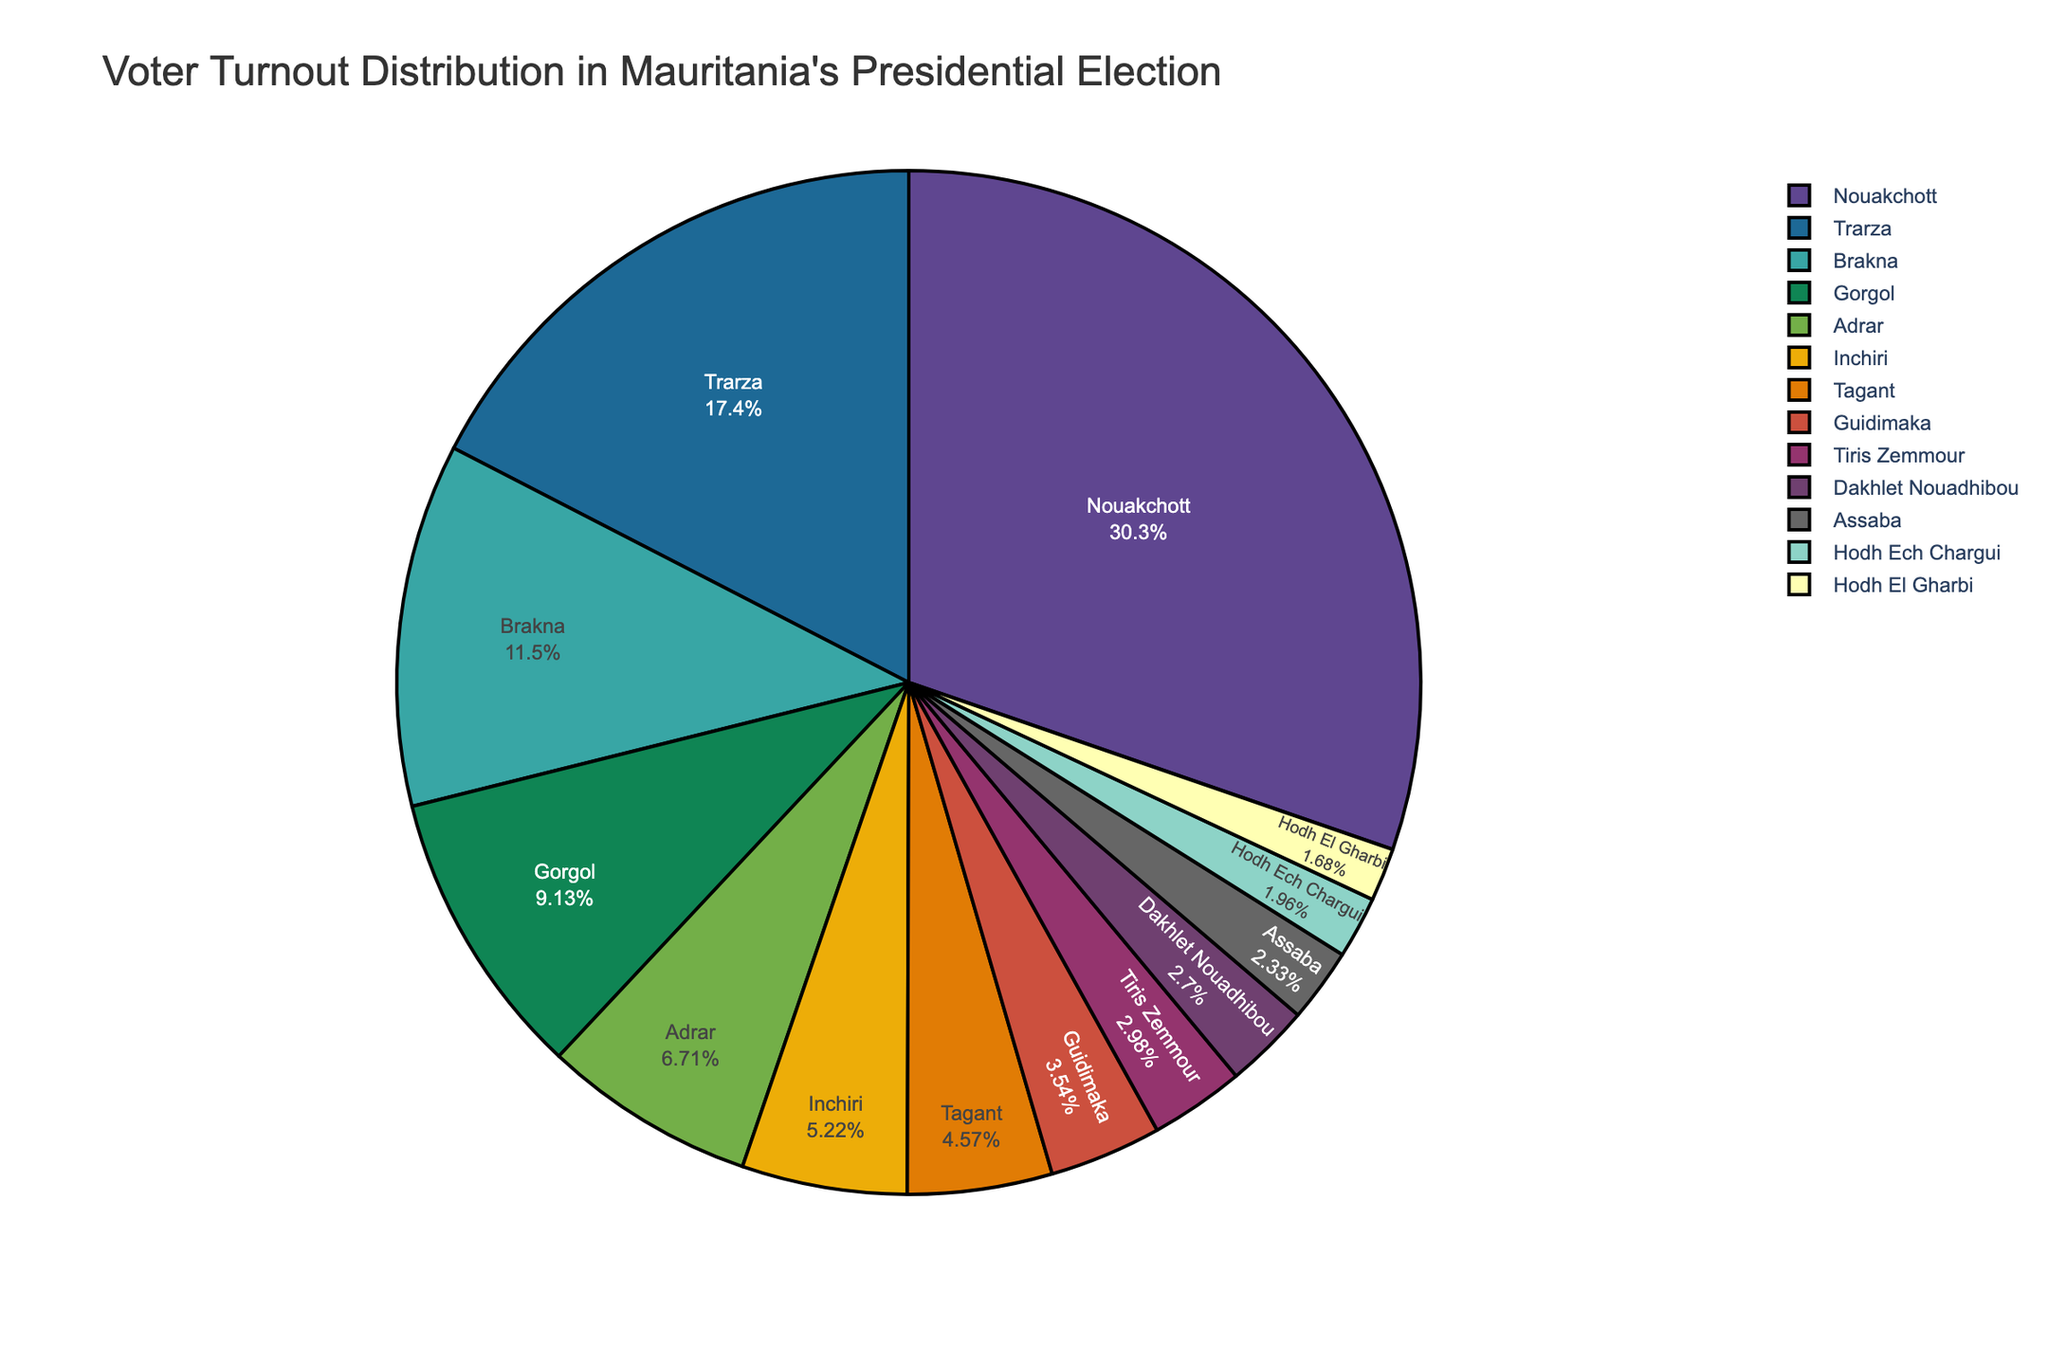What percentage of voter turnout is represented by Nouakchott? Look at the pie chart and find Nouakchott. The percentage of voter turnout for Nouakchott is directly shown next to its label.
Answer: 32.5% Which region has the smallest voter turnout percentage and what is that percentage? Find the smallest segment in the pie chart and identify the corresponding region. Look at the label of that region to find the voter turnout percentage.
Answer: Hodh El Gharbi, 1.8% What is the combined voter turnout percentage for Brakna and Gorgol? Find the segments for Brakna and Gorgol in the pie chart. Add their voter turnout percentages: 12.3% (Brakna) + 9.8% (Gorgol).
Answer: 22.1% Compare the voter turnout percentages of Trarza and Tiris Zemmour. Which region has a higher voter turnout? Locate the segments for Trarza and Tiris Zemmour in the pie chart. Compare the percentages given: 18.7% for Trarza and 3.2% for Tiris Zemmour.
Answer: Trarza What is the difference in voter turnout percentage between Inchiri and Adrar? Find the segments for Inchiri and Adrar in the pie chart. Subtract the smaller percentage from the larger one: 7.2% - 5.6%.
Answer: 1.6% How does the voter turnout percentage of Assaba compare to that of Tagant? Look at the pie chart segments for Assaba and Tagant and note their percentages: 2.5% for Assaba and 4.9% for Tagant.
Answer: Assaba has a lower voter turnout than Tagant Which regions have a voter turnout percentage below 5%? Identify segments in the pie chart with percentages below 5%. The regions are Inchiri, Tagant, Guidimaka, Tiris Zemmour, Dakhlet Nouadhibou, Assaba, Hodh Ech Chargui, and Hodh El Gharbi.
Answer: Inchiri, Tagant, Guidimaka, Tiris Zemmour, Dakhlet Nouadhibou, Assaba, Hodh Ech Chargui, Hodh El Gharbi What is the total voter turnout percentage for all regions except Nouakchott? Subtract Nouakchott's percentage (32.5%) from 100% (the total percentage).
Answer: 67.5% Please compare the combined voter turnout percentage of Hodh Ech Chargui, Hodh El Gharbi, and Assaba with that of Trarza. Which is higher? Find the segments for Hodh Ech Chargui, Hodh El Gharbi, and Assaba and sum their percentages: 2.1% + 1.8% + 2.5% = 6.4%. Compare this with Trarza's percentage of 18.7%.
Answer: Trarza is higher What regions have a voter turnout percentage above 10%? Identify segments in the pie chart with percentages above 10%. The regions with this criterion are Nouakchott, Trarza, and Brakna.
Answer: Nouakchott, Trarza, Brakna 